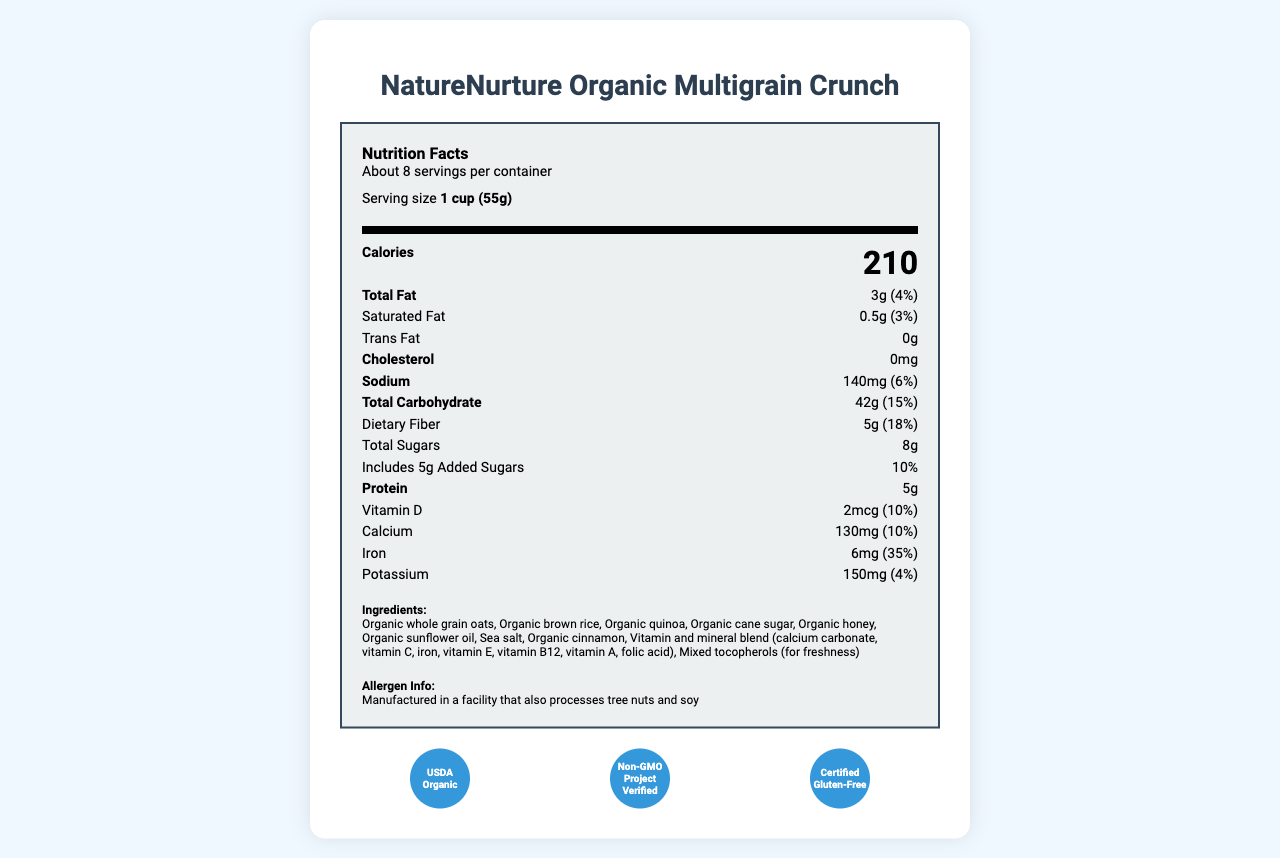what is the serving size? The serving size is clearly listed under the "Serving size" label as 1 cup (55g).
Answer: 1 cup (55g) how many calories are in a serving? The calories per serving are listed prominently in bold as 210 calories.
Answer: 210 what is the daily value percentage of iron per serving? The daily value percentage of iron is listed next to the amount (6mg) as 35%.
Answer: 35% what are the first three ingredients listed? The first three ingredients are listed at the beginning of the ingredients list.
Answer: Organic whole grain oats, Organic brown rice, Organic quinoa how many servings are in the container? The number of servings per container is stated as "About 8" near the top of the label.
Answer: About 8 which vitamin has the highest daily value percentage? A. Vitamin D B. Calcium C. Vitamin B12 D. Folic Acid The daily value percentage for folic acid is 100%, which is higher than the other vitamins listed.
Answer: D what is the total fat content per serving? A. 0g B. 3g C. 5g D. 8g The total fat content per serving is 3g, listed next to the "Total Fat" label.
Answer: B is this cereal gluten-free? The certifications section includes the "Certified Gluten-Free" label, indicating the cereal is gluten-free.
Answer: Yes does the product contain any artificial colors? One of the marketing claims states "No artificial colors, flavors, or preservatives," indicating there are no artificial colors.
Answer: No summarize the key nutritional information and features of this cereal. The document provides these key details, summarizing the nutritional content, ingredient integrity, and certifications, as well as emphasizing the health benefits.
Answer: This organic gluten-free cereal, NatureNurture Organic Multigrain Crunch, provides 210 calories per serving (1 cup). It contains 3g of total fat, 0.5g of saturated fat, 140mg of sodium, 42g of total carbohydrates (including 5g of dietary fiber and 8g of sugars), and 5g of protein. The cereal is fortified with essential vitamins and minerals such as Vitamin D, Calcium, Iron, and Folic Acid. It is made with whole grains, has no artificial colors, flavors, or preservatives, and is certified USDA Organic, Non-GMO, and Gluten-Free. what are the storage instructions for this cereal? The storage instructions are clearly listed towards the end of the document.
Answer: Store in a cool, dry place. For maximum freshness, consume within 30 days of opening. is the product made by HealthyHarvest Foods, Inc.? The manufacturer is listed as HealthyHarvest Foods, Inc., with an address provided.
Answer: Yes what is the primary benefit highlighted regarding this cereal's fiber content? One of the marketing claims highlights that the cereal is an "excellent source of fiber."
Answer: Excellent source of fiber how much potassium is in each serving? The potassium content per serving is listed as 150mg.
Answer: 150mg does the document specify an expiration date for the product? The document does not include any information regarding the expiration date of the product.
Answer: Cannot be determined 